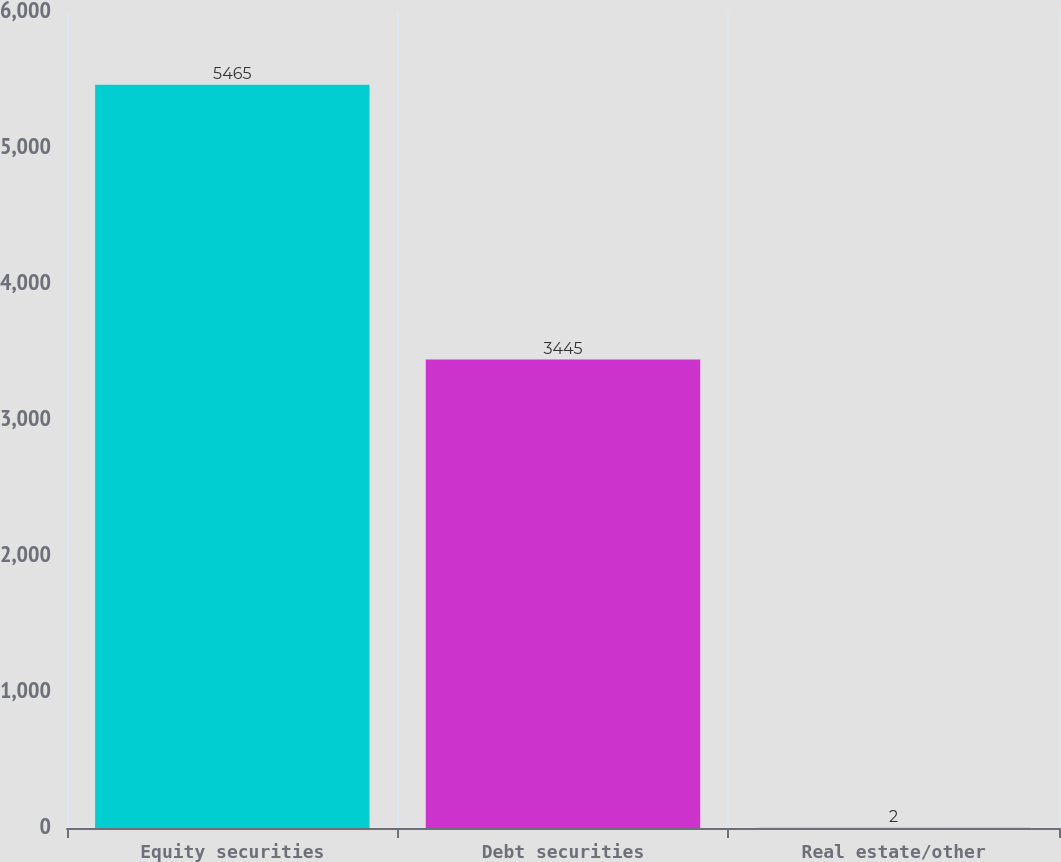<chart> <loc_0><loc_0><loc_500><loc_500><bar_chart><fcel>Equity securities<fcel>Debt securities<fcel>Real estate/other<nl><fcel>5465<fcel>3445<fcel>2<nl></chart> 